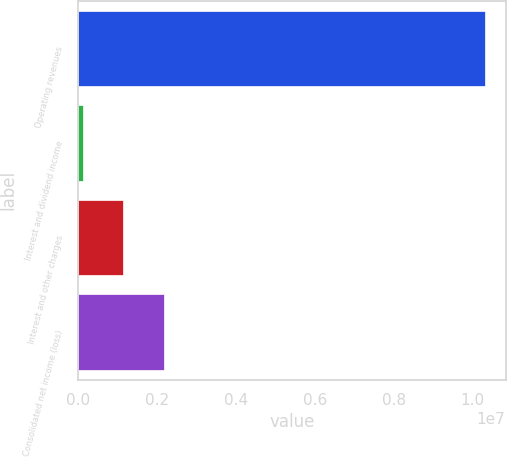<chart> <loc_0><loc_0><loc_500><loc_500><bar_chart><fcel>Operating revenues<fcel>Interest and dividend income<fcel>Interest and other charges<fcel>Consolidated net income (loss)<nl><fcel>1.03186e+07<fcel>122657<fcel>1.14225e+06<fcel>2.16185e+06<nl></chart> 